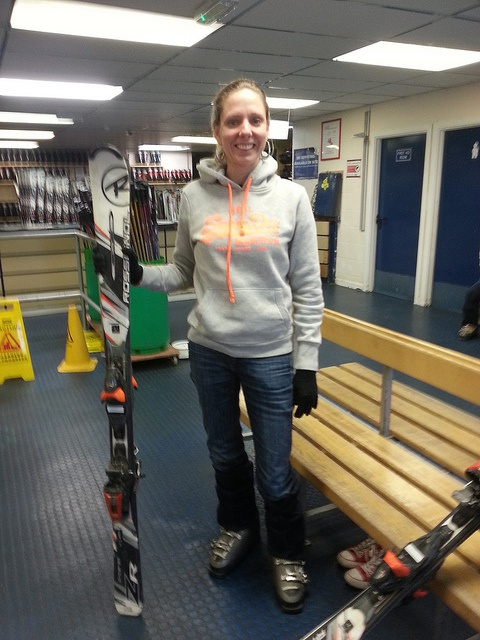Describe the objects in this image and their specific colors. I can see people in gray, black, darkgray, and ivory tones, bench in gray, tan, and olive tones, snowboard in gray, black, darkgray, and lightgray tones, skis in gray, black, darkgray, and lightgray tones, and skis in gray, black, and beige tones in this image. 